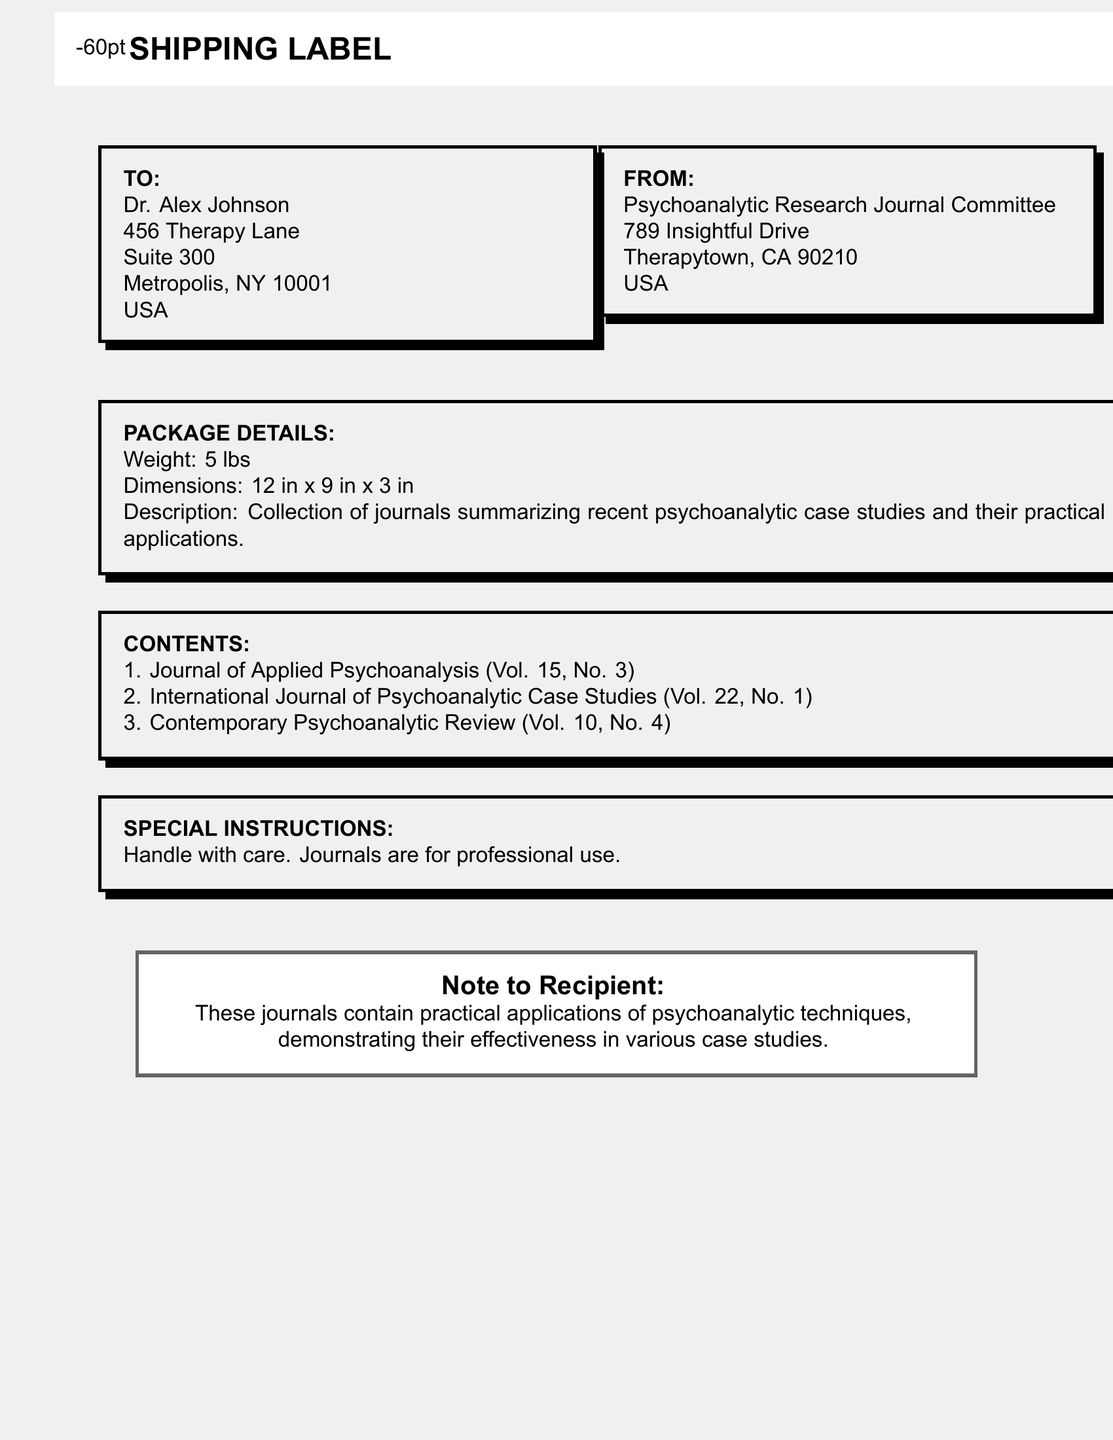What is the name of the recipient? The recipient's name is listed under "TO" in the document as Dr. Alex Johnson.
Answer: Dr. Alex Johnson What is the weight of the package? The weight of the package is mentioned under "PACKAGE DETAILS."
Answer: 5 lbs What are the dimensions of the package? The dimensions of the package are found in the same section as the weight, specifying the size format.
Answer: 12 in x 9 in x 3 in What is the content of the first journal listed? The first journal is detailed in the "CONTENTS" section, listing its volume and issue number.
Answer: Journal of Applied Psychoanalysis (Vol. 15, No. 3) What special instructions are provided for the package? The special instructions are outlined in a dedicated section, indicating handling care.
Answer: Handle with care. Journals are for professional use What is the address of the sender? The sender's address is included under "FROM," detailing the location of the Psychoanalytic Research Journal Committee.
Answer: 789 Insightful Drive, Therapytown, CA 90210, USA What is the primary focus of the journals? The note to the recipient describes the content's focus, emphasizing practical applications in psychoanalysis.
Answer: Practical applications of psychoanalytic techniques How many journals are included in the package? The "CONTENTS" section lists three journals, indicating the quantity of items sent.
Answer: 3 What city does the recipient reside in? The recipient's city is part of their address listed under "TO," providing the location details.
Answer: Metropolis What is the title of the second journal mentioned? The title of the second journal appears in the "CONTENTS" section, which states its name explicitly.
Answer: International Journal of Psychoanalytic Case Studies (Vol. 22, No. 1) 